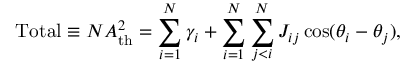Convert formula to latex. <formula><loc_0><loc_0><loc_500><loc_500>T o t a l \equiv N A _ { t h } ^ { 2 } = \sum _ { i = 1 } ^ { N } \gamma _ { i } + \sum _ { i = 1 } ^ { N } \sum _ { j < i } ^ { N } J _ { i j } \cos ( \theta _ { i } - \theta _ { j } ) ,</formula> 